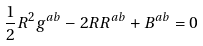Convert formula to latex. <formula><loc_0><loc_0><loc_500><loc_500>\frac { 1 } { 2 } R ^ { 2 } g ^ { a b } - 2 R R ^ { a b } + B ^ { a b } = 0</formula> 